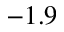Convert formula to latex. <formula><loc_0><loc_0><loc_500><loc_500>- 1 . 9</formula> 